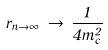<formula> <loc_0><loc_0><loc_500><loc_500>r _ { n \rightarrow \infty } \, \rightarrow \, \frac { 1 } { 4 \bar { m } _ { c } ^ { 2 } }</formula> 